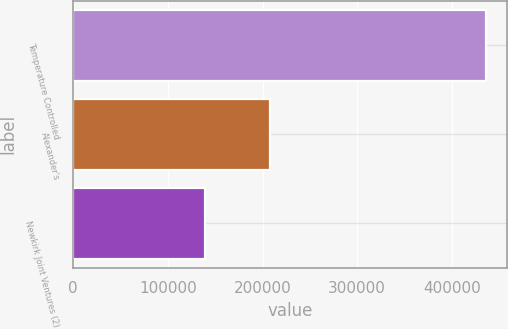Convert chart to OTSL. <chart><loc_0><loc_0><loc_500><loc_500><bar_chart><fcel>Temperature Controlled<fcel>Alexander's<fcel>Newkirk Joint Ventures (2)<nl><fcel>436225<fcel>207872<fcel>138762<nl></chart> 